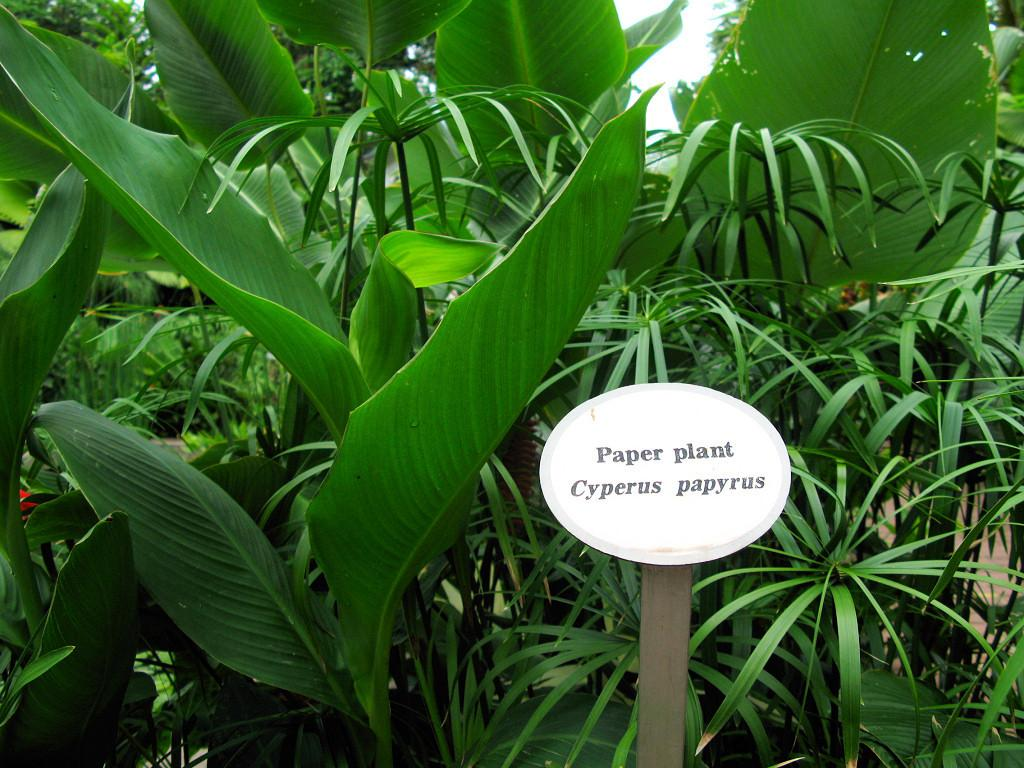What is located in the foreground of the picture? There is a board and plants in the foreground of the picture. Can you describe the plants in the foreground? The plants in the foreground are not specified, but they are present. What can be seen in the background of the picture? There are trees in the background of the picture. Where can people go for a haircut in the image? There is no information about a haircut or a place to get one in the image. Is there an amusement park visible in the image? There is no mention of an amusement park or any related features in the image. 